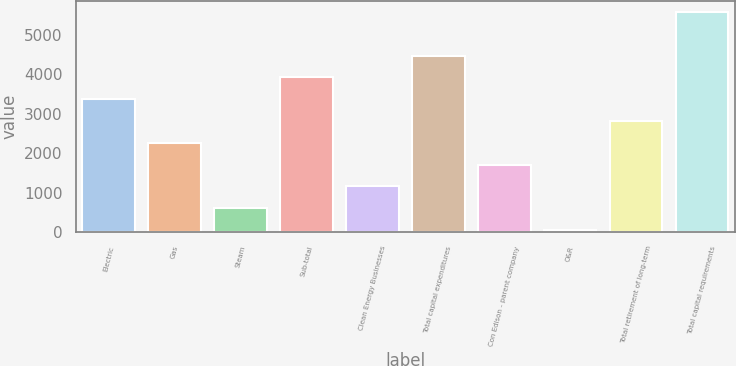Convert chart to OTSL. <chart><loc_0><loc_0><loc_500><loc_500><bar_chart><fcel>Electric<fcel>Gas<fcel>Steam<fcel>Sub-total<fcel>Clean Energy Businesses<fcel>Total capital expenditures<fcel>Con Edison - parent company<fcel>O&R<fcel>Total retirement of long-term<fcel>Total capital requirements<nl><fcel>3365.2<fcel>2261.8<fcel>606.7<fcel>3916.9<fcel>1158.4<fcel>4468.6<fcel>1710.1<fcel>55<fcel>2813.5<fcel>5572<nl></chart> 